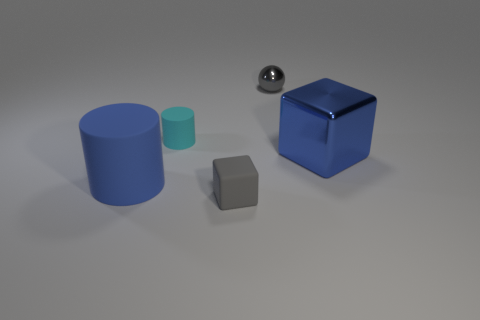Add 3 large purple blocks. How many objects exist? 8 Subtract all blocks. How many objects are left? 3 Subtract 1 balls. How many balls are left? 0 Subtract all purple blocks. How many yellow cylinders are left? 0 Subtract all tiny green cubes. Subtract all blue rubber objects. How many objects are left? 4 Add 3 small gray things. How many small gray things are left? 5 Add 4 small cyan things. How many small cyan things exist? 5 Subtract 1 blue cubes. How many objects are left? 4 Subtract all blue cylinders. Subtract all cyan balls. How many cylinders are left? 1 